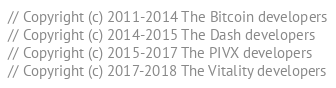<code> <loc_0><loc_0><loc_500><loc_500><_C++_>// Copyright (c) 2011-2014 The Bitcoin developers
// Copyright (c) 2014-2015 The Dash developers
// Copyright (c) 2015-2017 The PIVX developers
// Copyright (c) 2017-2018 The Vitality developers</code> 